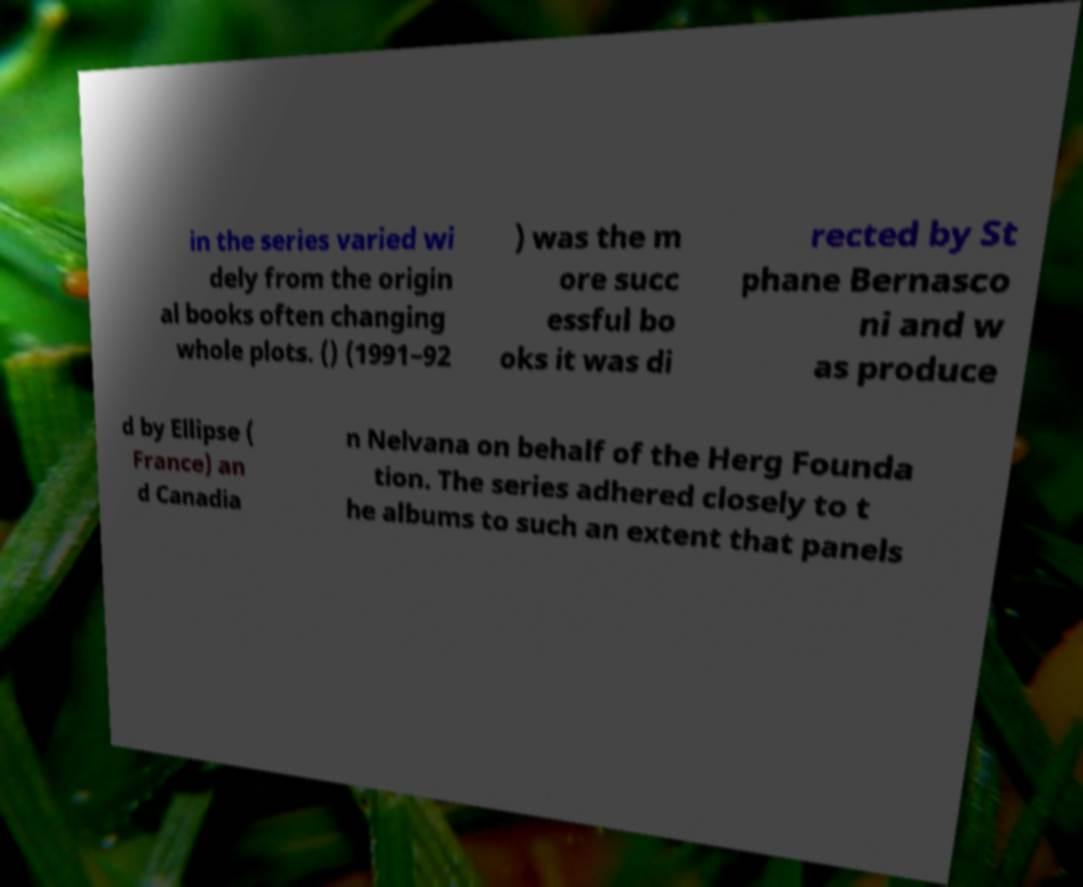There's text embedded in this image that I need extracted. Can you transcribe it verbatim? in the series varied wi dely from the origin al books often changing whole plots. () (1991–92 ) was the m ore succ essful bo oks it was di rected by St phane Bernasco ni and w as produce d by Ellipse ( France) an d Canadia n Nelvana on behalf of the Herg Founda tion. The series adhered closely to t he albums to such an extent that panels 